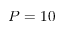<formula> <loc_0><loc_0><loc_500><loc_500>P = 1 0</formula> 